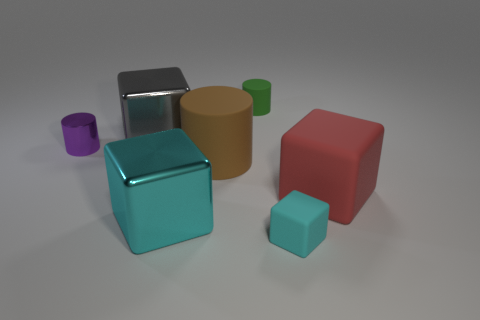Add 1 metallic cylinders. How many objects exist? 8 Subtract 0 purple cubes. How many objects are left? 7 Subtract all cubes. How many objects are left? 3 Subtract 1 cylinders. How many cylinders are left? 2 Subtract all brown cylinders. Subtract all purple blocks. How many cylinders are left? 2 Subtract all blue blocks. How many green cylinders are left? 1 Subtract all tiny cyan objects. Subtract all large blue shiny cylinders. How many objects are left? 6 Add 6 brown rubber objects. How many brown rubber objects are left? 7 Add 7 large red objects. How many large red objects exist? 8 Subtract all cyan cubes. How many cubes are left? 2 